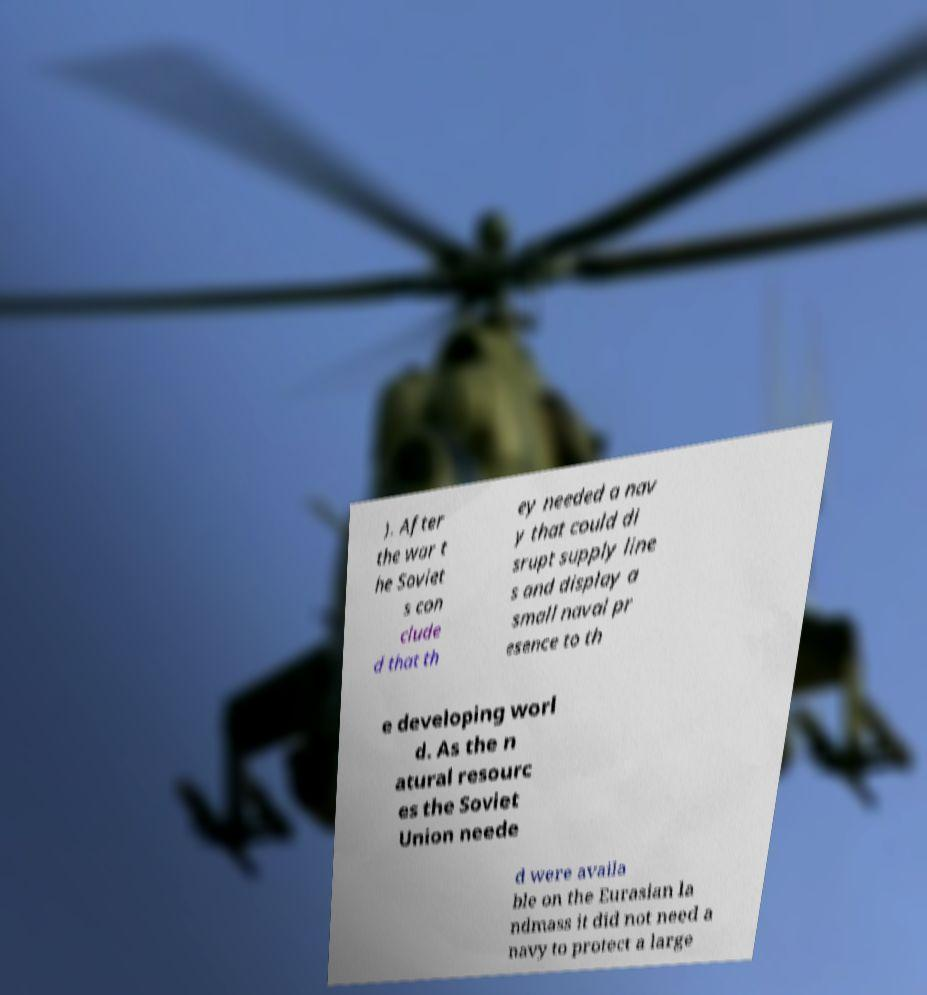Can you read and provide the text displayed in the image?This photo seems to have some interesting text. Can you extract and type it out for me? ). After the war t he Soviet s con clude d that th ey needed a nav y that could di srupt supply line s and display a small naval pr esence to th e developing worl d. As the n atural resourc es the Soviet Union neede d were availa ble on the Eurasian la ndmass it did not need a navy to protect a large 